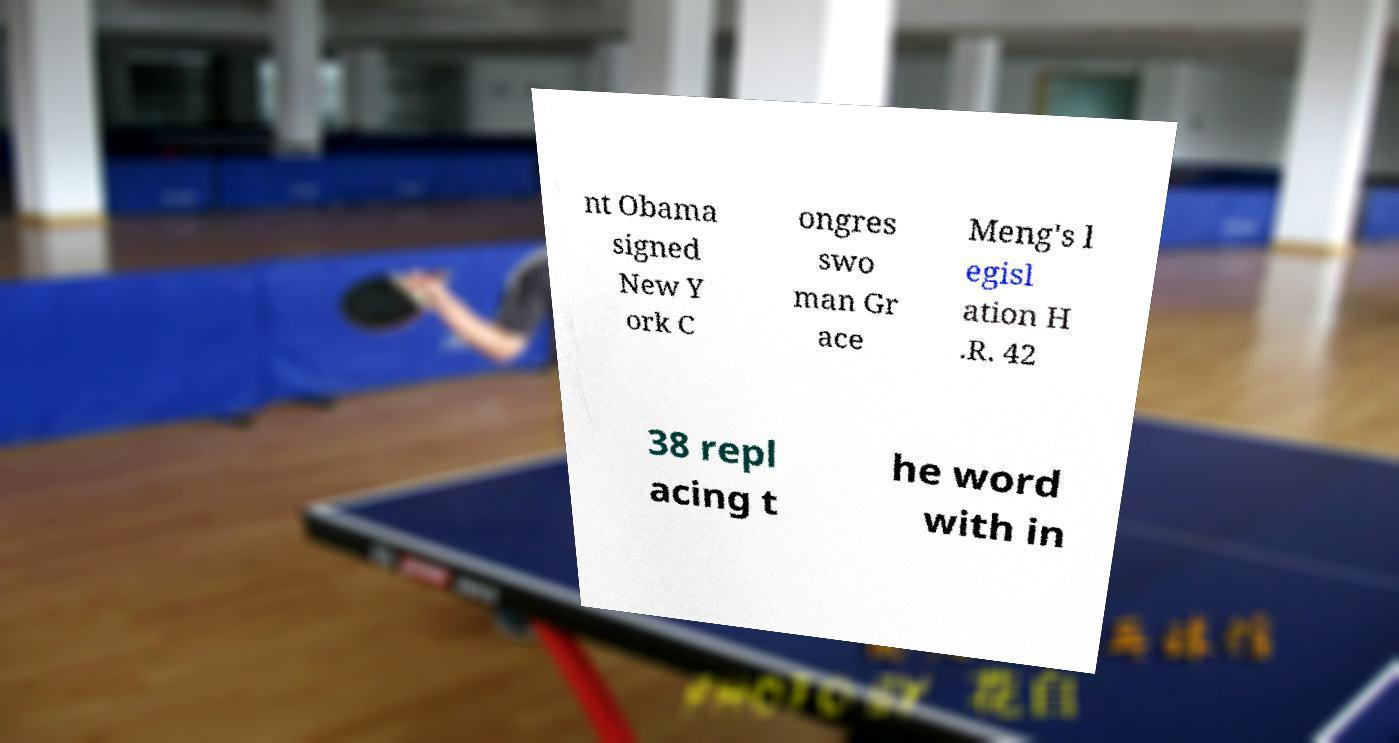Can you accurately transcribe the text from the provided image for me? nt Obama signed New Y ork C ongres swo man Gr ace Meng's l egisl ation H .R. 42 38 repl acing t he word with in 